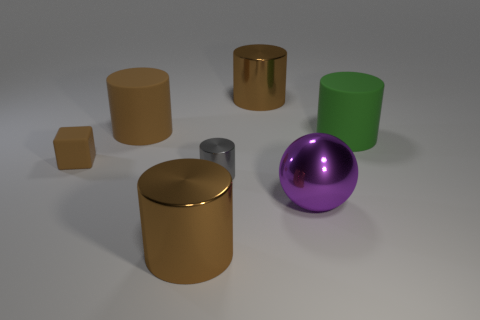What number of other rubber things are the same shape as the small brown thing?
Keep it short and to the point. 0. There is a brown thing that is both on the left side of the tiny gray metallic object and behind the small block; what material is it?
Give a very brief answer. Rubber. Do the green cylinder and the large ball have the same material?
Your response must be concise. No. How many small brown objects are there?
Your response must be concise. 1. What color is the rubber object to the right of the large metal cylinder behind the brown metal cylinder in front of the ball?
Your answer should be very brief. Green. Is the color of the sphere the same as the small shiny cylinder?
Give a very brief answer. No. What number of shiny objects are in front of the tiny gray object and left of the metallic sphere?
Provide a succinct answer. 1. What number of metal things are either large objects or red spheres?
Ensure brevity in your answer.  3. What is the material of the big brown cylinder on the left side of the brown cylinder in front of the big purple sphere?
Offer a very short reply. Rubber. What is the shape of the big rubber object that is the same color as the rubber cube?
Provide a short and direct response. Cylinder. 